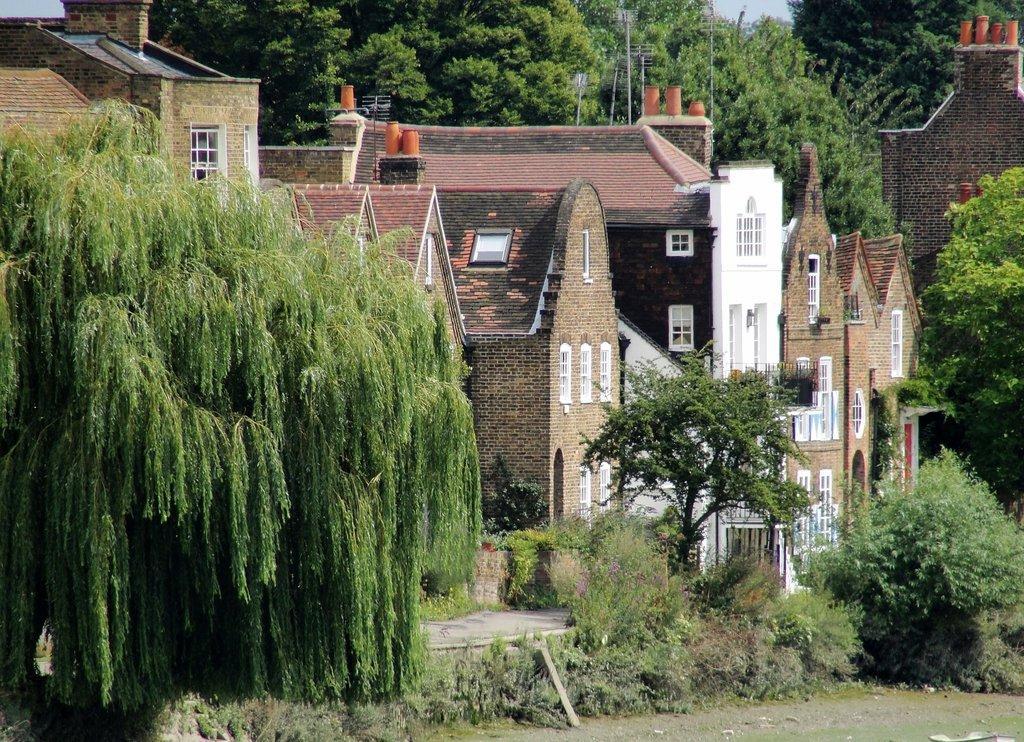How would you summarize this image in a sentence or two? In this image there are trees and houses. 